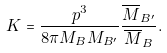<formula> <loc_0><loc_0><loc_500><loc_500>K = \frac { p ^ { 3 } } { 8 \pi M _ { B } M _ { B ^ { \prime } } } \frac { \overline { M } _ { B ^ { \prime } } } { \overline { M } _ { B } } .</formula> 